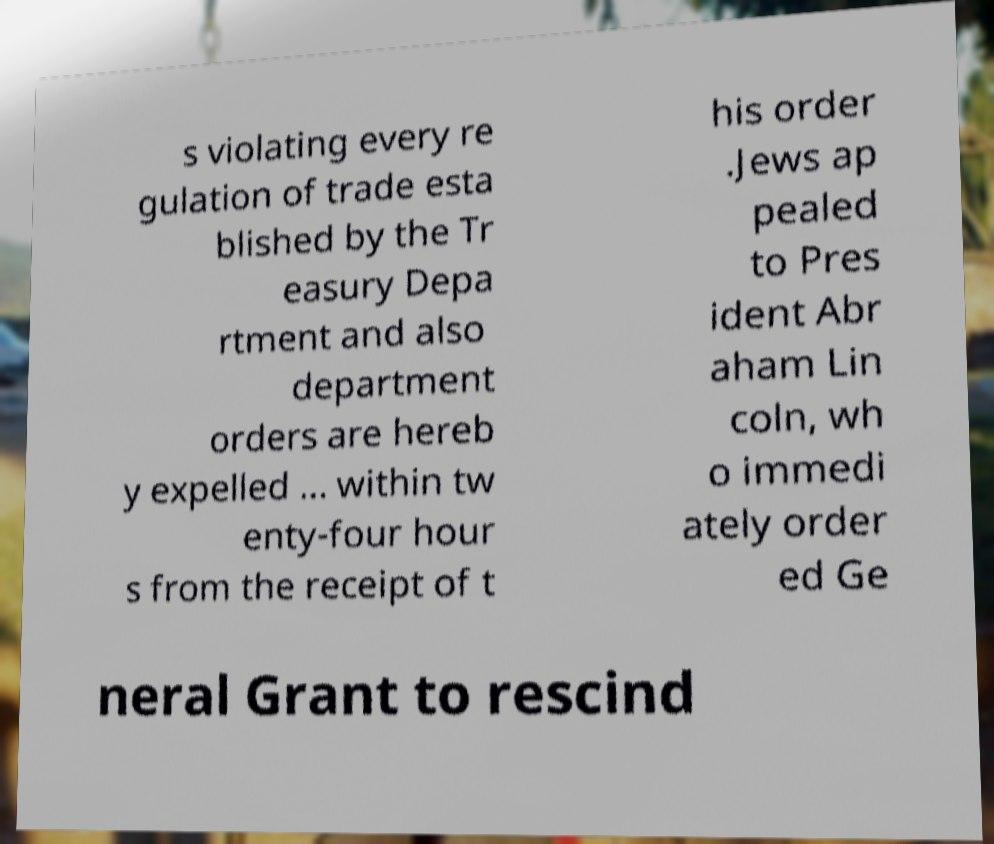I need the written content from this picture converted into text. Can you do that? s violating every re gulation of trade esta blished by the Tr easury Depa rtment and also department orders are hereb y expelled ... within tw enty-four hour s from the receipt of t his order .Jews ap pealed to Pres ident Abr aham Lin coln, wh o immedi ately order ed Ge neral Grant to rescind 